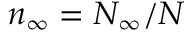<formula> <loc_0><loc_0><loc_500><loc_500>n _ { \infty } = N _ { \infty } / N</formula> 